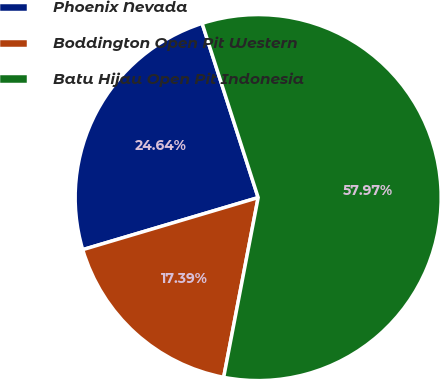<chart> <loc_0><loc_0><loc_500><loc_500><pie_chart><fcel>Phoenix Nevada<fcel>Boddington Open Pit Western<fcel>Batu Hijau Open Pit Indonesia<nl><fcel>24.64%<fcel>17.39%<fcel>57.97%<nl></chart> 